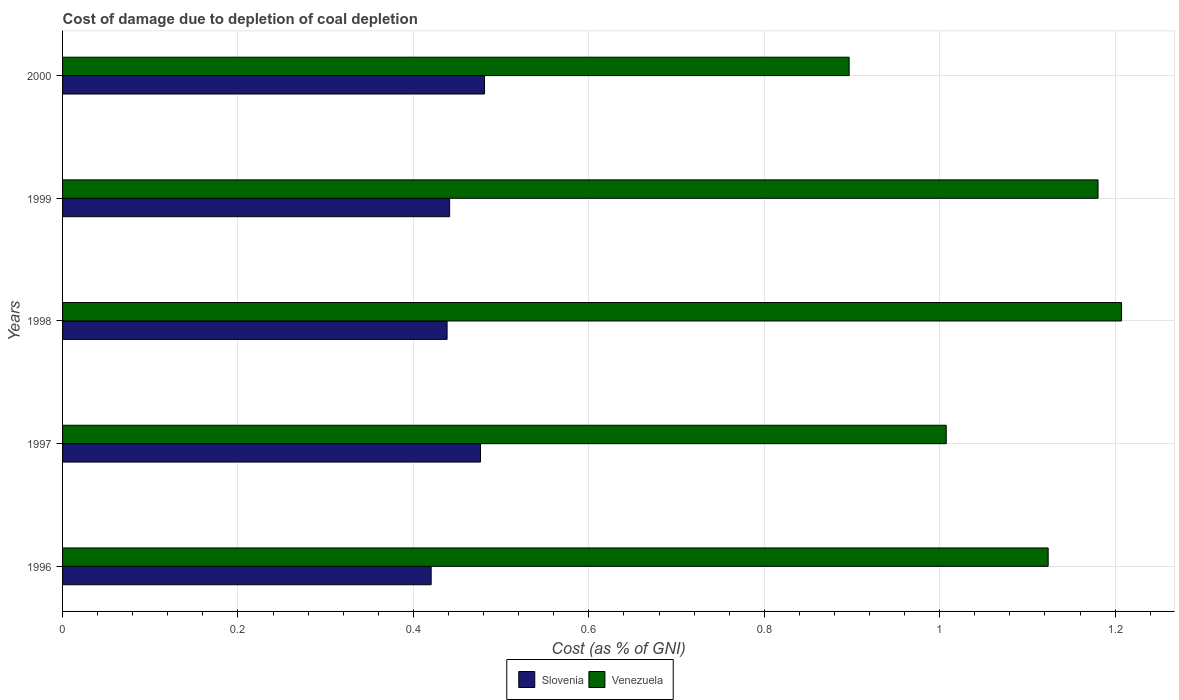How many groups of bars are there?
Your answer should be compact. 5. Are the number of bars per tick equal to the number of legend labels?
Give a very brief answer. Yes. Are the number of bars on each tick of the Y-axis equal?
Offer a terse response. Yes. How many bars are there on the 5th tick from the top?
Your answer should be very brief. 2. How many bars are there on the 3rd tick from the bottom?
Your answer should be very brief. 2. In how many cases, is the number of bars for a given year not equal to the number of legend labels?
Your answer should be very brief. 0. What is the cost of damage caused due to coal depletion in Venezuela in 1997?
Give a very brief answer. 1.01. Across all years, what is the maximum cost of damage caused due to coal depletion in Venezuela?
Your response must be concise. 1.21. Across all years, what is the minimum cost of damage caused due to coal depletion in Venezuela?
Your answer should be compact. 0.9. In which year was the cost of damage caused due to coal depletion in Venezuela minimum?
Provide a short and direct response. 2000. What is the total cost of damage caused due to coal depletion in Venezuela in the graph?
Provide a short and direct response. 5.42. What is the difference between the cost of damage caused due to coal depletion in Slovenia in 1998 and that in 1999?
Offer a terse response. -0. What is the difference between the cost of damage caused due to coal depletion in Slovenia in 1996 and the cost of damage caused due to coal depletion in Venezuela in 1997?
Make the answer very short. -0.59. What is the average cost of damage caused due to coal depletion in Venezuela per year?
Ensure brevity in your answer.  1.08. In the year 1997, what is the difference between the cost of damage caused due to coal depletion in Venezuela and cost of damage caused due to coal depletion in Slovenia?
Your response must be concise. 0.53. What is the ratio of the cost of damage caused due to coal depletion in Slovenia in 1996 to that in 1998?
Keep it short and to the point. 0.96. What is the difference between the highest and the second highest cost of damage caused due to coal depletion in Slovenia?
Your answer should be very brief. 0. What is the difference between the highest and the lowest cost of damage caused due to coal depletion in Slovenia?
Make the answer very short. 0.06. Is the sum of the cost of damage caused due to coal depletion in Venezuela in 1997 and 2000 greater than the maximum cost of damage caused due to coal depletion in Slovenia across all years?
Offer a very short reply. Yes. What does the 1st bar from the top in 2000 represents?
Make the answer very short. Venezuela. What does the 2nd bar from the bottom in 1997 represents?
Give a very brief answer. Venezuela. How many bars are there?
Offer a terse response. 10. Are all the bars in the graph horizontal?
Ensure brevity in your answer.  Yes. Where does the legend appear in the graph?
Provide a succinct answer. Bottom center. How many legend labels are there?
Ensure brevity in your answer.  2. How are the legend labels stacked?
Give a very brief answer. Horizontal. What is the title of the graph?
Make the answer very short. Cost of damage due to depletion of coal depletion. What is the label or title of the X-axis?
Make the answer very short. Cost (as % of GNI). What is the label or title of the Y-axis?
Offer a very short reply. Years. What is the Cost (as % of GNI) in Slovenia in 1996?
Your answer should be compact. 0.42. What is the Cost (as % of GNI) of Venezuela in 1996?
Make the answer very short. 1.12. What is the Cost (as % of GNI) in Slovenia in 1997?
Give a very brief answer. 0.48. What is the Cost (as % of GNI) in Venezuela in 1997?
Offer a very short reply. 1.01. What is the Cost (as % of GNI) of Slovenia in 1998?
Give a very brief answer. 0.44. What is the Cost (as % of GNI) of Venezuela in 1998?
Provide a succinct answer. 1.21. What is the Cost (as % of GNI) of Slovenia in 1999?
Give a very brief answer. 0.44. What is the Cost (as % of GNI) of Venezuela in 1999?
Provide a succinct answer. 1.18. What is the Cost (as % of GNI) in Slovenia in 2000?
Keep it short and to the point. 0.48. What is the Cost (as % of GNI) of Venezuela in 2000?
Offer a terse response. 0.9. Across all years, what is the maximum Cost (as % of GNI) of Slovenia?
Your response must be concise. 0.48. Across all years, what is the maximum Cost (as % of GNI) of Venezuela?
Offer a very short reply. 1.21. Across all years, what is the minimum Cost (as % of GNI) of Slovenia?
Ensure brevity in your answer.  0.42. Across all years, what is the minimum Cost (as % of GNI) in Venezuela?
Offer a very short reply. 0.9. What is the total Cost (as % of GNI) in Slovenia in the graph?
Provide a short and direct response. 2.26. What is the total Cost (as % of GNI) of Venezuela in the graph?
Offer a terse response. 5.42. What is the difference between the Cost (as % of GNI) in Slovenia in 1996 and that in 1997?
Give a very brief answer. -0.06. What is the difference between the Cost (as % of GNI) in Venezuela in 1996 and that in 1997?
Keep it short and to the point. 0.12. What is the difference between the Cost (as % of GNI) in Slovenia in 1996 and that in 1998?
Keep it short and to the point. -0.02. What is the difference between the Cost (as % of GNI) in Venezuela in 1996 and that in 1998?
Offer a very short reply. -0.08. What is the difference between the Cost (as % of GNI) in Slovenia in 1996 and that in 1999?
Offer a terse response. -0.02. What is the difference between the Cost (as % of GNI) in Venezuela in 1996 and that in 1999?
Provide a succinct answer. -0.06. What is the difference between the Cost (as % of GNI) of Slovenia in 1996 and that in 2000?
Offer a very short reply. -0.06. What is the difference between the Cost (as % of GNI) in Venezuela in 1996 and that in 2000?
Your answer should be very brief. 0.23. What is the difference between the Cost (as % of GNI) in Slovenia in 1997 and that in 1998?
Keep it short and to the point. 0.04. What is the difference between the Cost (as % of GNI) in Venezuela in 1997 and that in 1998?
Offer a very short reply. -0.2. What is the difference between the Cost (as % of GNI) in Slovenia in 1997 and that in 1999?
Make the answer very short. 0.04. What is the difference between the Cost (as % of GNI) of Venezuela in 1997 and that in 1999?
Provide a short and direct response. -0.17. What is the difference between the Cost (as % of GNI) in Slovenia in 1997 and that in 2000?
Offer a very short reply. -0. What is the difference between the Cost (as % of GNI) of Venezuela in 1997 and that in 2000?
Make the answer very short. 0.11. What is the difference between the Cost (as % of GNI) of Slovenia in 1998 and that in 1999?
Provide a short and direct response. -0. What is the difference between the Cost (as % of GNI) of Venezuela in 1998 and that in 1999?
Give a very brief answer. 0.03. What is the difference between the Cost (as % of GNI) in Slovenia in 1998 and that in 2000?
Provide a short and direct response. -0.04. What is the difference between the Cost (as % of GNI) in Venezuela in 1998 and that in 2000?
Ensure brevity in your answer.  0.31. What is the difference between the Cost (as % of GNI) of Slovenia in 1999 and that in 2000?
Offer a very short reply. -0.04. What is the difference between the Cost (as % of GNI) of Venezuela in 1999 and that in 2000?
Your answer should be compact. 0.28. What is the difference between the Cost (as % of GNI) of Slovenia in 1996 and the Cost (as % of GNI) of Venezuela in 1997?
Your answer should be very brief. -0.59. What is the difference between the Cost (as % of GNI) in Slovenia in 1996 and the Cost (as % of GNI) in Venezuela in 1998?
Provide a short and direct response. -0.79. What is the difference between the Cost (as % of GNI) in Slovenia in 1996 and the Cost (as % of GNI) in Venezuela in 1999?
Your response must be concise. -0.76. What is the difference between the Cost (as % of GNI) in Slovenia in 1996 and the Cost (as % of GNI) in Venezuela in 2000?
Make the answer very short. -0.48. What is the difference between the Cost (as % of GNI) of Slovenia in 1997 and the Cost (as % of GNI) of Venezuela in 1998?
Ensure brevity in your answer.  -0.73. What is the difference between the Cost (as % of GNI) of Slovenia in 1997 and the Cost (as % of GNI) of Venezuela in 1999?
Your answer should be very brief. -0.7. What is the difference between the Cost (as % of GNI) of Slovenia in 1997 and the Cost (as % of GNI) of Venezuela in 2000?
Provide a succinct answer. -0.42. What is the difference between the Cost (as % of GNI) in Slovenia in 1998 and the Cost (as % of GNI) in Venezuela in 1999?
Offer a very short reply. -0.74. What is the difference between the Cost (as % of GNI) in Slovenia in 1998 and the Cost (as % of GNI) in Venezuela in 2000?
Ensure brevity in your answer.  -0.46. What is the difference between the Cost (as % of GNI) in Slovenia in 1999 and the Cost (as % of GNI) in Venezuela in 2000?
Offer a terse response. -0.46. What is the average Cost (as % of GNI) of Slovenia per year?
Make the answer very short. 0.45. What is the average Cost (as % of GNI) of Venezuela per year?
Provide a short and direct response. 1.08. In the year 1996, what is the difference between the Cost (as % of GNI) of Slovenia and Cost (as % of GNI) of Venezuela?
Offer a terse response. -0.7. In the year 1997, what is the difference between the Cost (as % of GNI) in Slovenia and Cost (as % of GNI) in Venezuela?
Your response must be concise. -0.53. In the year 1998, what is the difference between the Cost (as % of GNI) of Slovenia and Cost (as % of GNI) of Venezuela?
Make the answer very short. -0.77. In the year 1999, what is the difference between the Cost (as % of GNI) in Slovenia and Cost (as % of GNI) in Venezuela?
Give a very brief answer. -0.74. In the year 2000, what is the difference between the Cost (as % of GNI) of Slovenia and Cost (as % of GNI) of Venezuela?
Provide a short and direct response. -0.42. What is the ratio of the Cost (as % of GNI) in Slovenia in 1996 to that in 1997?
Ensure brevity in your answer.  0.88. What is the ratio of the Cost (as % of GNI) of Venezuela in 1996 to that in 1997?
Offer a very short reply. 1.12. What is the ratio of the Cost (as % of GNI) of Slovenia in 1996 to that in 1998?
Your answer should be compact. 0.96. What is the ratio of the Cost (as % of GNI) in Venezuela in 1996 to that in 1998?
Make the answer very short. 0.93. What is the ratio of the Cost (as % of GNI) of Slovenia in 1996 to that in 1999?
Provide a succinct answer. 0.95. What is the ratio of the Cost (as % of GNI) of Venezuela in 1996 to that in 1999?
Give a very brief answer. 0.95. What is the ratio of the Cost (as % of GNI) of Slovenia in 1996 to that in 2000?
Offer a very short reply. 0.87. What is the ratio of the Cost (as % of GNI) in Venezuela in 1996 to that in 2000?
Provide a short and direct response. 1.25. What is the ratio of the Cost (as % of GNI) in Slovenia in 1997 to that in 1998?
Make the answer very short. 1.09. What is the ratio of the Cost (as % of GNI) in Venezuela in 1997 to that in 1998?
Make the answer very short. 0.83. What is the ratio of the Cost (as % of GNI) of Slovenia in 1997 to that in 1999?
Your response must be concise. 1.08. What is the ratio of the Cost (as % of GNI) of Venezuela in 1997 to that in 1999?
Give a very brief answer. 0.85. What is the ratio of the Cost (as % of GNI) in Venezuela in 1997 to that in 2000?
Offer a very short reply. 1.12. What is the ratio of the Cost (as % of GNI) in Slovenia in 1998 to that in 1999?
Ensure brevity in your answer.  0.99. What is the ratio of the Cost (as % of GNI) in Venezuela in 1998 to that in 1999?
Your answer should be very brief. 1.02. What is the ratio of the Cost (as % of GNI) of Slovenia in 1998 to that in 2000?
Provide a short and direct response. 0.91. What is the ratio of the Cost (as % of GNI) of Venezuela in 1998 to that in 2000?
Keep it short and to the point. 1.35. What is the ratio of the Cost (as % of GNI) in Slovenia in 1999 to that in 2000?
Provide a succinct answer. 0.92. What is the ratio of the Cost (as % of GNI) in Venezuela in 1999 to that in 2000?
Your response must be concise. 1.32. What is the difference between the highest and the second highest Cost (as % of GNI) of Slovenia?
Offer a terse response. 0. What is the difference between the highest and the second highest Cost (as % of GNI) in Venezuela?
Make the answer very short. 0.03. What is the difference between the highest and the lowest Cost (as % of GNI) of Slovenia?
Offer a very short reply. 0.06. What is the difference between the highest and the lowest Cost (as % of GNI) of Venezuela?
Give a very brief answer. 0.31. 